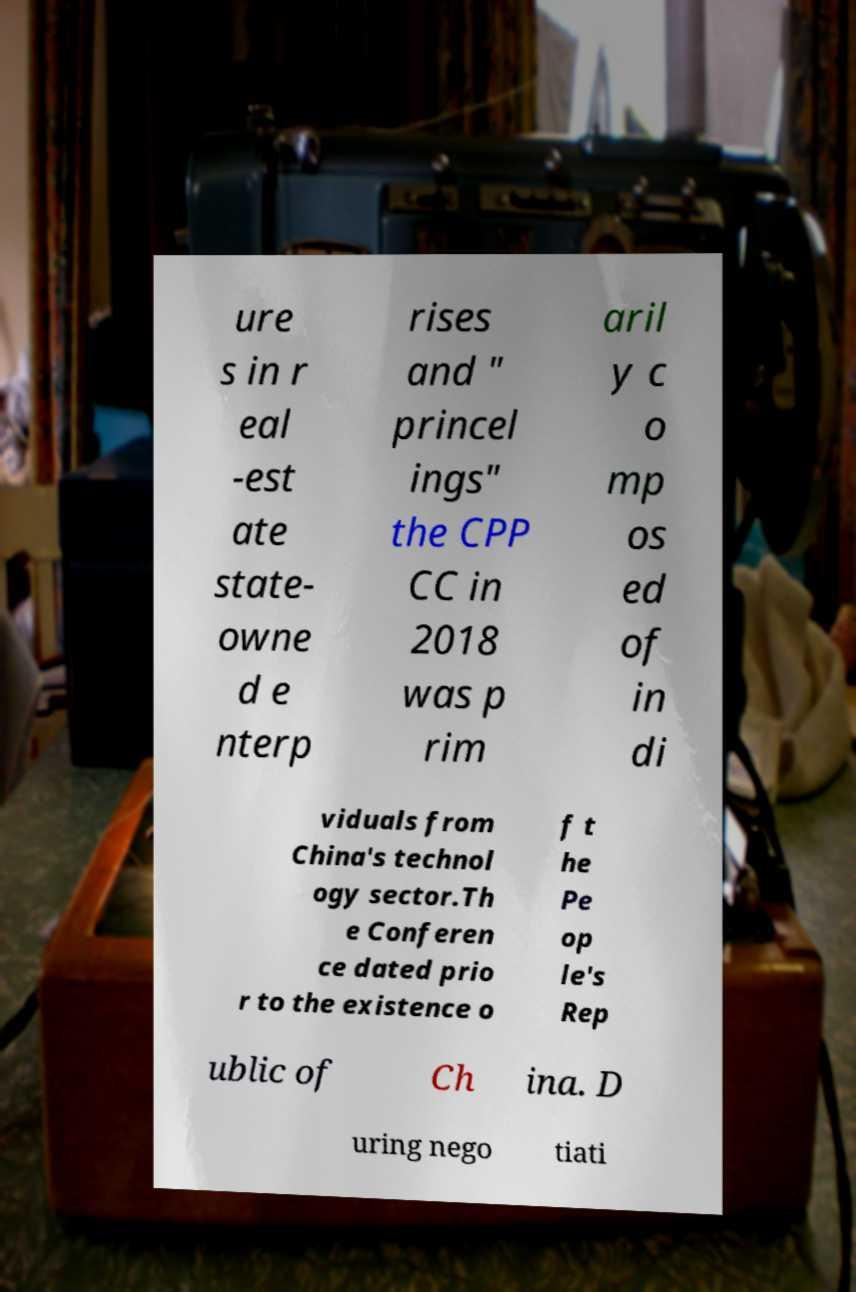I need the written content from this picture converted into text. Can you do that? ure s in r eal -est ate state- owne d e nterp rises and " princel ings" the CPP CC in 2018 was p rim aril y c o mp os ed of in di viduals from China's technol ogy sector.Th e Conferen ce dated prio r to the existence o f t he Pe op le's Rep ublic of Ch ina. D uring nego tiati 